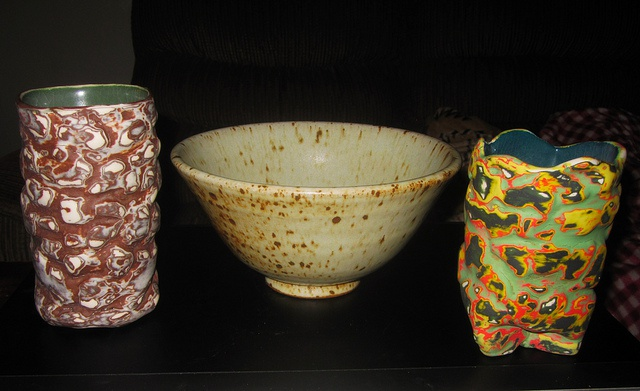Describe the objects in this image and their specific colors. I can see dining table in black, gray, olive, and maroon tones, bowl in black, tan, and olive tones, vase in black, maroon, brown, gray, and darkgray tones, cup in black, maroon, brown, gray, and darkgray tones, and vase in black, darkgreen, and olive tones in this image. 